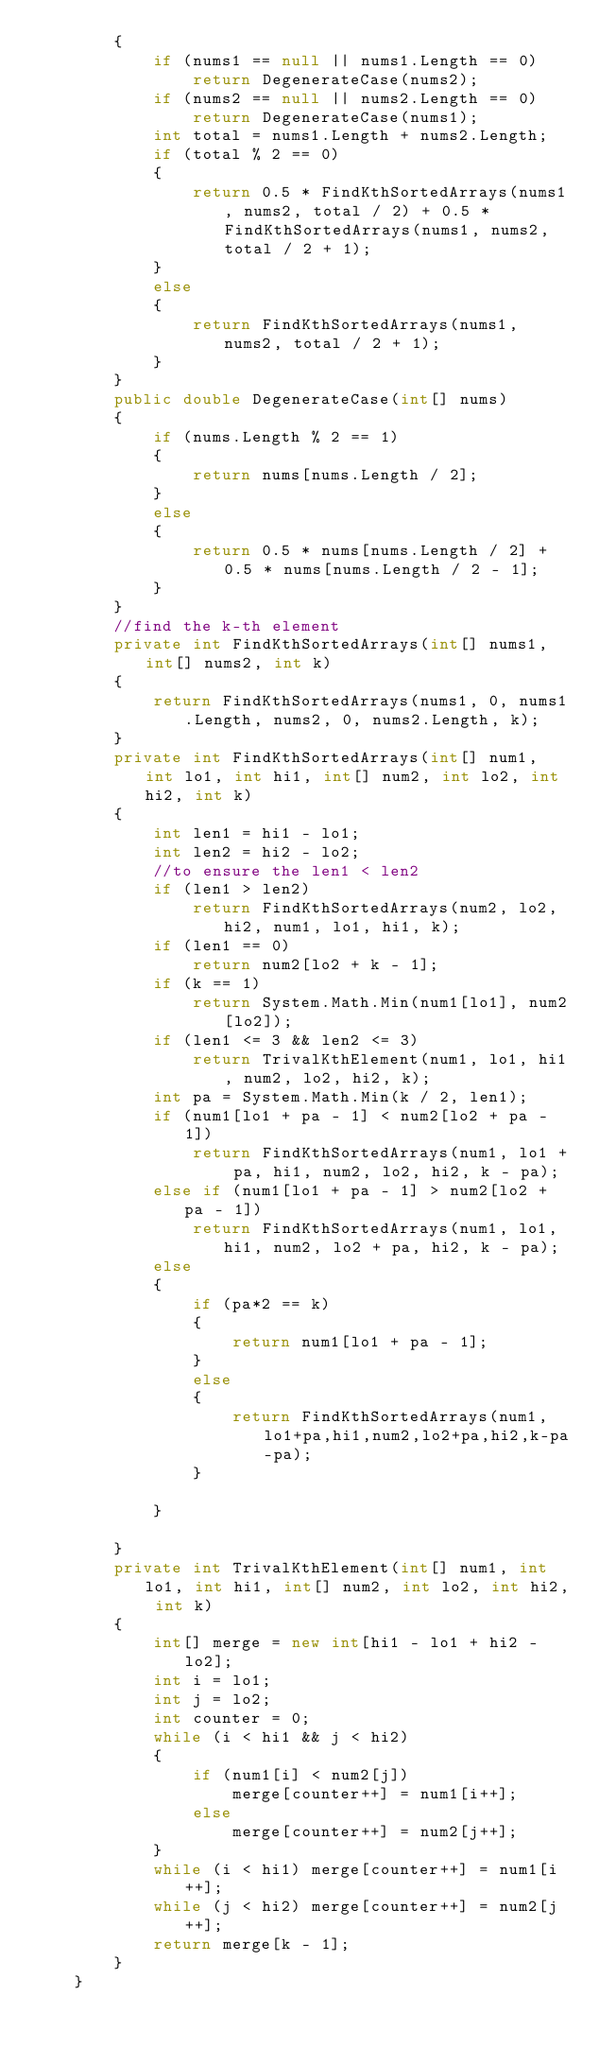Convert code to text. <code><loc_0><loc_0><loc_500><loc_500><_C#_>        {
            if (nums1 == null || nums1.Length == 0)
                return DegenerateCase(nums2);
            if (nums2 == null || nums2.Length == 0)
                return DegenerateCase(nums1);
            int total = nums1.Length + nums2.Length;
            if (total % 2 == 0)
            {
                return 0.5 * FindKthSortedArrays(nums1, nums2, total / 2) + 0.5 * FindKthSortedArrays(nums1, nums2, total / 2 + 1);
            }
            else
            {
                return FindKthSortedArrays(nums1, nums2, total / 2 + 1);
            }
        }
        public double DegenerateCase(int[] nums)
        {
            if (nums.Length % 2 == 1)
            {
                return nums[nums.Length / 2];
            }
            else
            {
                return 0.5 * nums[nums.Length / 2] + 0.5 * nums[nums.Length / 2 - 1];
            }
        }
        //find the k-th element
        private int FindKthSortedArrays(int[] nums1, int[] nums2, int k)
        {
            return FindKthSortedArrays(nums1, 0, nums1.Length, nums2, 0, nums2.Length, k);
        }
        private int FindKthSortedArrays(int[] num1, int lo1, int hi1, int[] num2, int lo2, int hi2, int k)
        {
            int len1 = hi1 - lo1;
            int len2 = hi2 - lo2;
            //to ensure the len1 < len2
            if (len1 > len2)
                return FindKthSortedArrays(num2, lo2, hi2, num1, lo1, hi1, k);
            if (len1 == 0)
                return num2[lo2 + k - 1];
            if (k == 1)
                return System.Math.Min(num1[lo1], num2[lo2]);
            if (len1 <= 3 && len2 <= 3)
                return TrivalKthElement(num1, lo1, hi1, num2, lo2, hi2, k);
            int pa = System.Math.Min(k / 2, len1);
            if (num1[lo1 + pa - 1] < num2[lo2 + pa - 1])
                return FindKthSortedArrays(num1, lo1 + pa, hi1, num2, lo2, hi2, k - pa);
            else if (num1[lo1 + pa - 1] > num2[lo2 + pa - 1])
                return FindKthSortedArrays(num1, lo1, hi1, num2, lo2 + pa, hi2, k - pa);
            else
            {
                if (pa*2 == k)
                {
                    return num1[lo1 + pa - 1];
                }
                else
                {
                    return FindKthSortedArrays(num1,lo1+pa,hi1,num2,lo2+pa,hi2,k-pa-pa);
                }
                
            }
                
        }
        private int TrivalKthElement(int[] num1, int lo1, int hi1, int[] num2, int lo2, int hi2, int k)
        {
            int[] merge = new int[hi1 - lo1 + hi2 - lo2];
            int i = lo1;
            int j = lo2;
            int counter = 0;
            while (i < hi1 && j < hi2)
            {
                if (num1[i] < num2[j])
                    merge[counter++] = num1[i++];
                else
                    merge[counter++] = num2[j++];
            }
            while (i < hi1) merge[counter++] = num1[i++];
            while (j < hi2) merge[counter++] = num2[j++];
            return merge[k - 1];
        }
    }</code> 